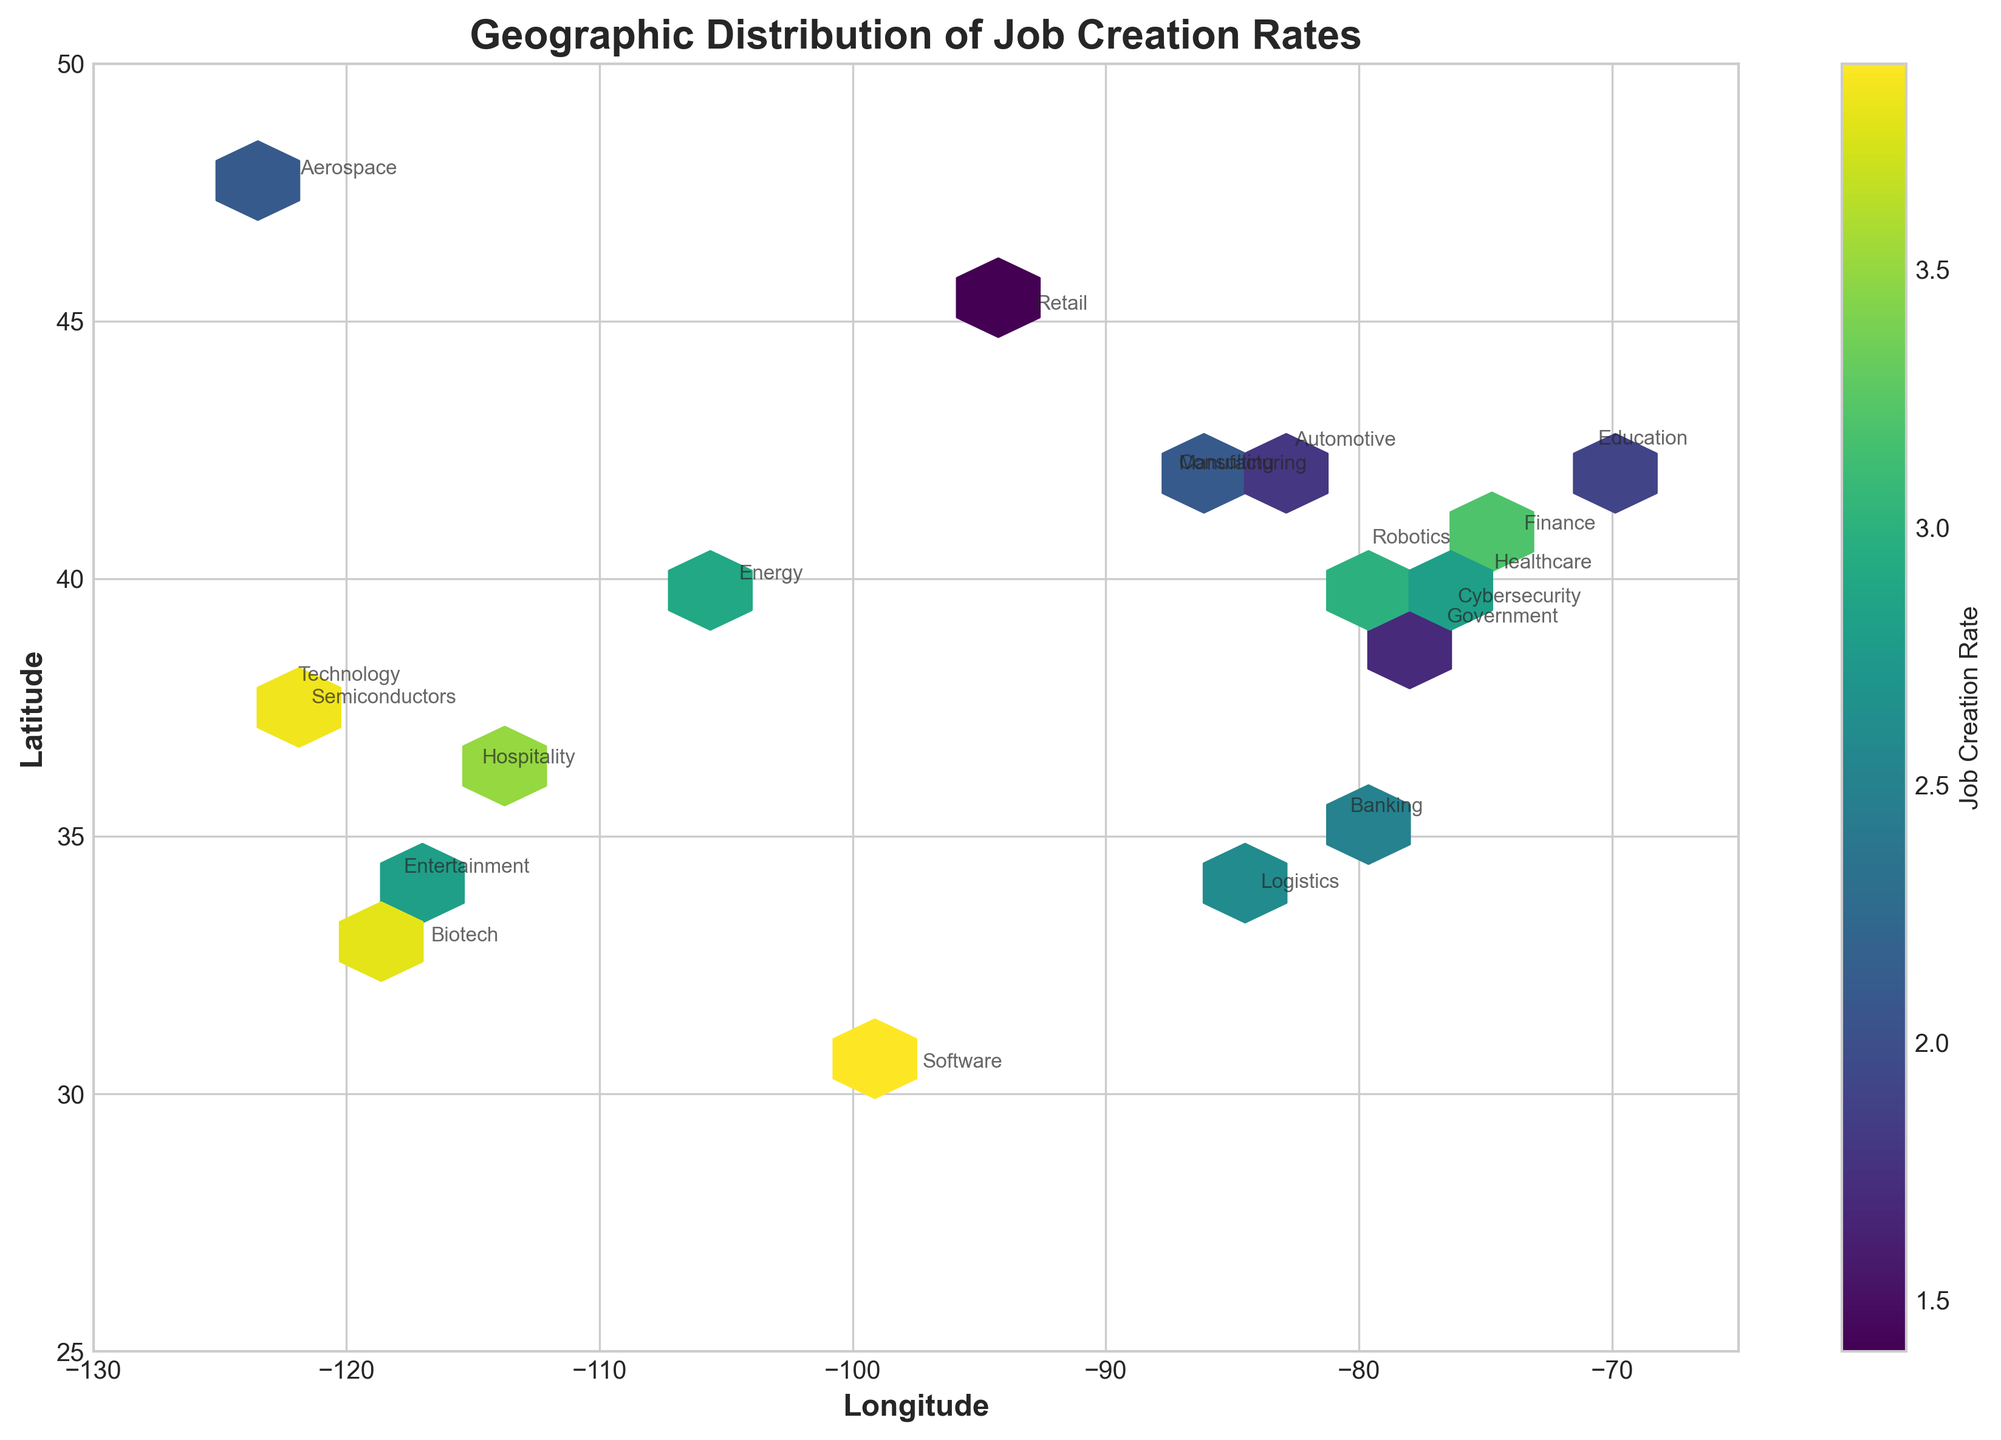Which city shows the highest job creation rate? The hexbin plot uses color intensities to show job creation rates. From the plot, the bright yellow areas indicate higher job creation rates. The brightest yellow one can be identified to locate the city with the highest rate.
Answer: San Diego What does the color bar represent in the figure? The color bar on the right side of the plot indicates the range and meaning of colors. In this plot, it represents the job creation rate, with darker colors for lower rates and brighter colors for higher rates.
Answer: Job creation rate How many metropolitan areas are represented in the plot? There are distinct points for each city shown on the plot, identified by their annotations. By counting these annotations, we can find the number of metropolitan areas.
Answer: 20 Which industry has a notable concentration in the northeast region? Look at the values in the northeastern section of the map (high latitude, east longitude). Identify the annotated industries in this region.
Answer: Healthcare Which industries are located around longitudes -100 and 35 latitude? Locate the area on the plot around these coordinates, and identify the annotations shown at those coordinates.
Answer: Energy and Banking What is the geographic location of the industry with the second-highest job creation rate? First, identify the highest job creation rate using color intensity, then look for the second brightest area and find the annotated industry.
Answer: Software in Austin, Texas Are there any clustered regions where multiple industries have similar job creation rates? Observe for regions in the plot where points or colors are clustered together, indicating similar job creation rates for different industries gathered in a geographic region.
Answer: Yes, several clusters, including around Los Angeles Which area has a lower job creation rate: Northeast or Southeast? Compare the color intensities represented in the northeastern and southeastern sections of the plot. Darker colors indicate lower job creation rates.
Answer: Northeast (darker shades) Can you spot any geographic pattern related to job creation in the western versus eastern United States? Compare the color intensities and the density (clusters) of hexbin plots in the western and eastern parts of the United States. Notice any consistency in color differences (brighter vs. darker) between these regions.
Answer: Western areas generally have higher job creation rates (brighter colors) Which city has a more diverse mix of industries with varying job creation rates: Washington D.C. or Chicago? Check the annotations and corresponding colors around the coordinates of Washington D.C. and Chicago on the plot. Compare the number of industries and differences in job creation rates shown by color intensities.
Answer: Washington D.C 